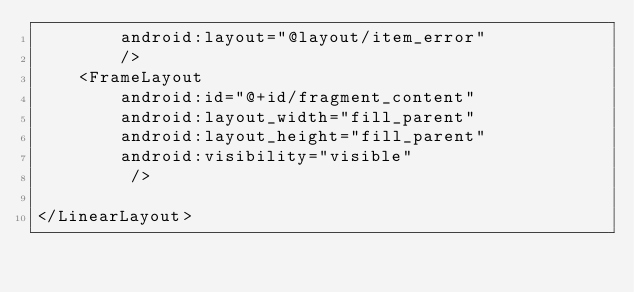Convert code to text. <code><loc_0><loc_0><loc_500><loc_500><_XML_>        android:layout="@layout/item_error"
	    />
    <FrameLayout
        android:id="@+id/fragment_content"
        android:layout_width="fill_parent"
        android:layout_height="fill_parent"
        android:visibility="visible"
         />

</LinearLayout></code> 